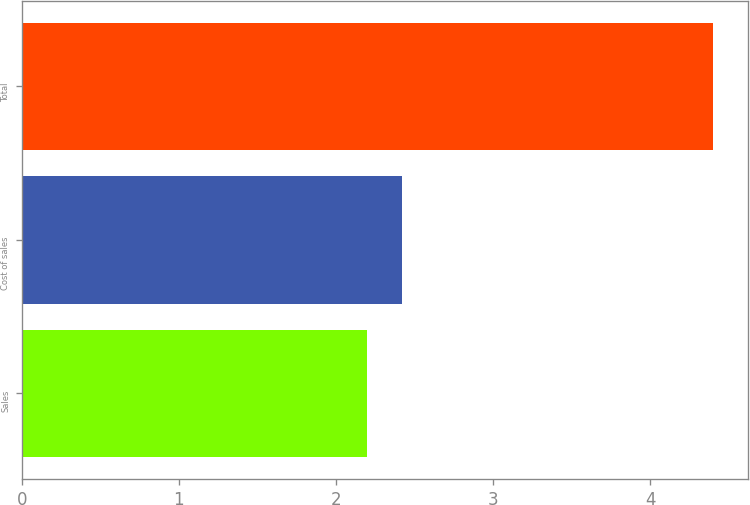<chart> <loc_0><loc_0><loc_500><loc_500><bar_chart><fcel>Sales<fcel>Cost of sales<fcel>Total<nl><fcel>2.2<fcel>2.42<fcel>4.4<nl></chart> 